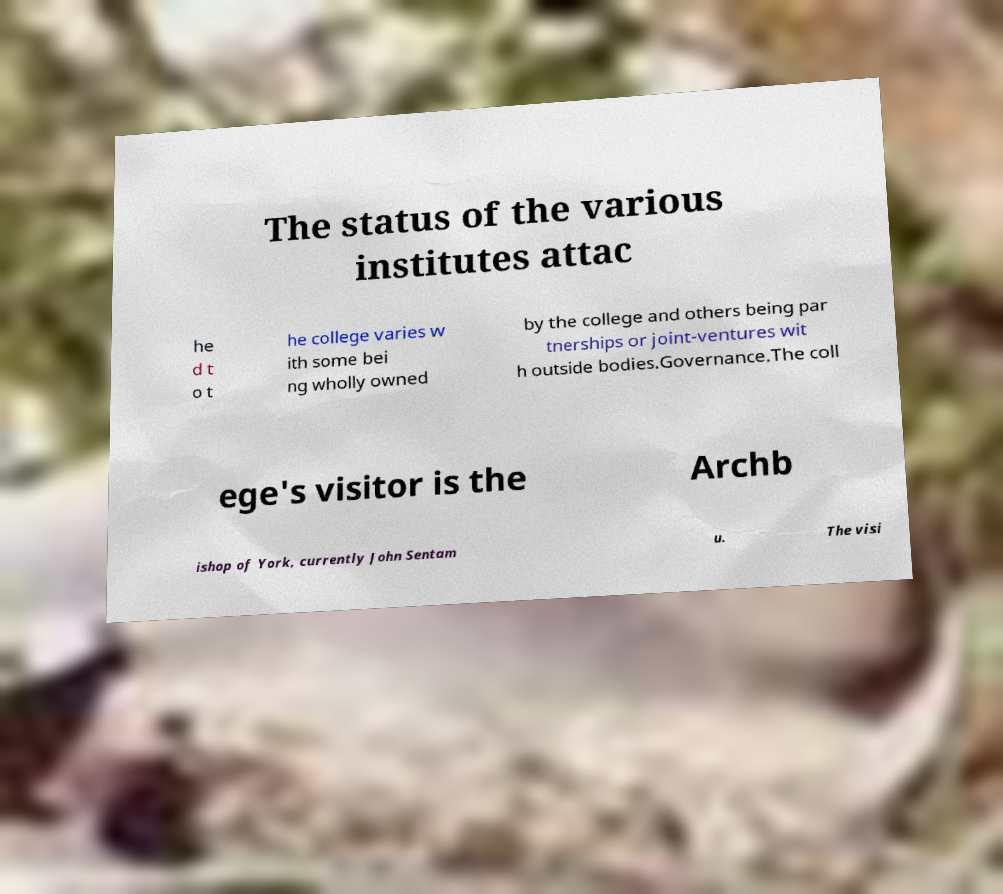Please read and relay the text visible in this image. What does it say? The status of the various institutes attac he d t o t he college varies w ith some bei ng wholly owned by the college and others being par tnerships or joint-ventures wit h outside bodies.Governance.The coll ege's visitor is the Archb ishop of York, currently John Sentam u. The visi 